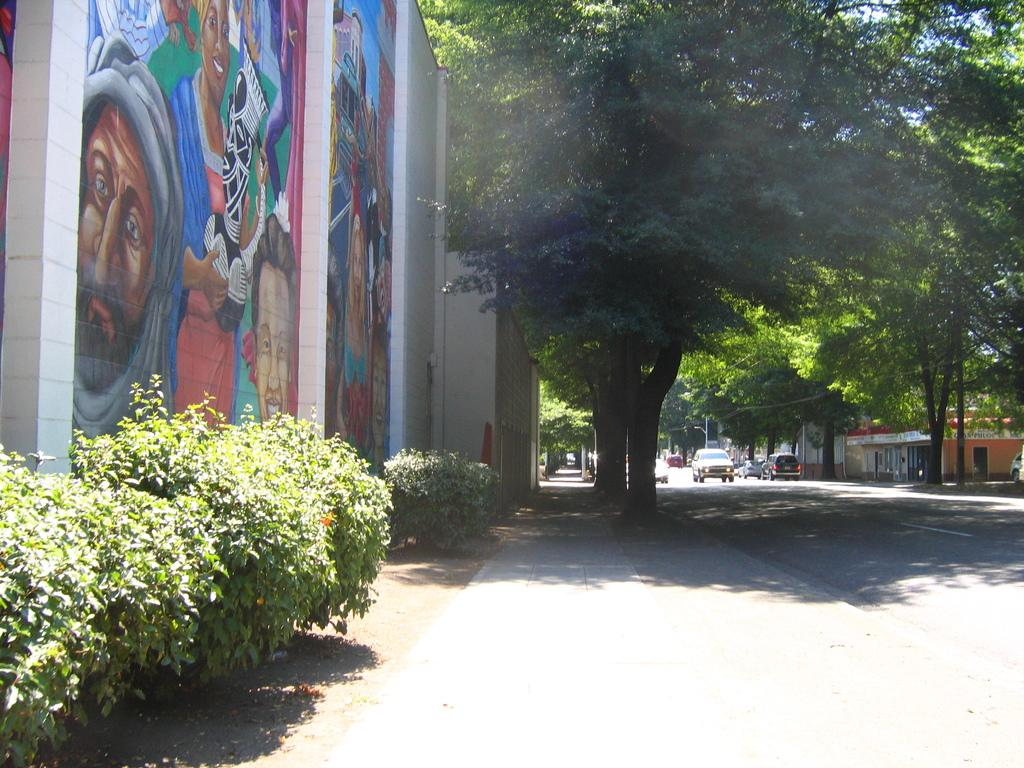What is present on the wall in the image? The wall has some painting on it. What type of structures can be seen in the image? There are houses visible in the image. What natural elements are present in the image? There are trees and plants in the image. Can you tell me how many bikes are parked near the houses in the image? There is no bike present in the image; only houses, trees, plants, and a wall with painting are visible. 